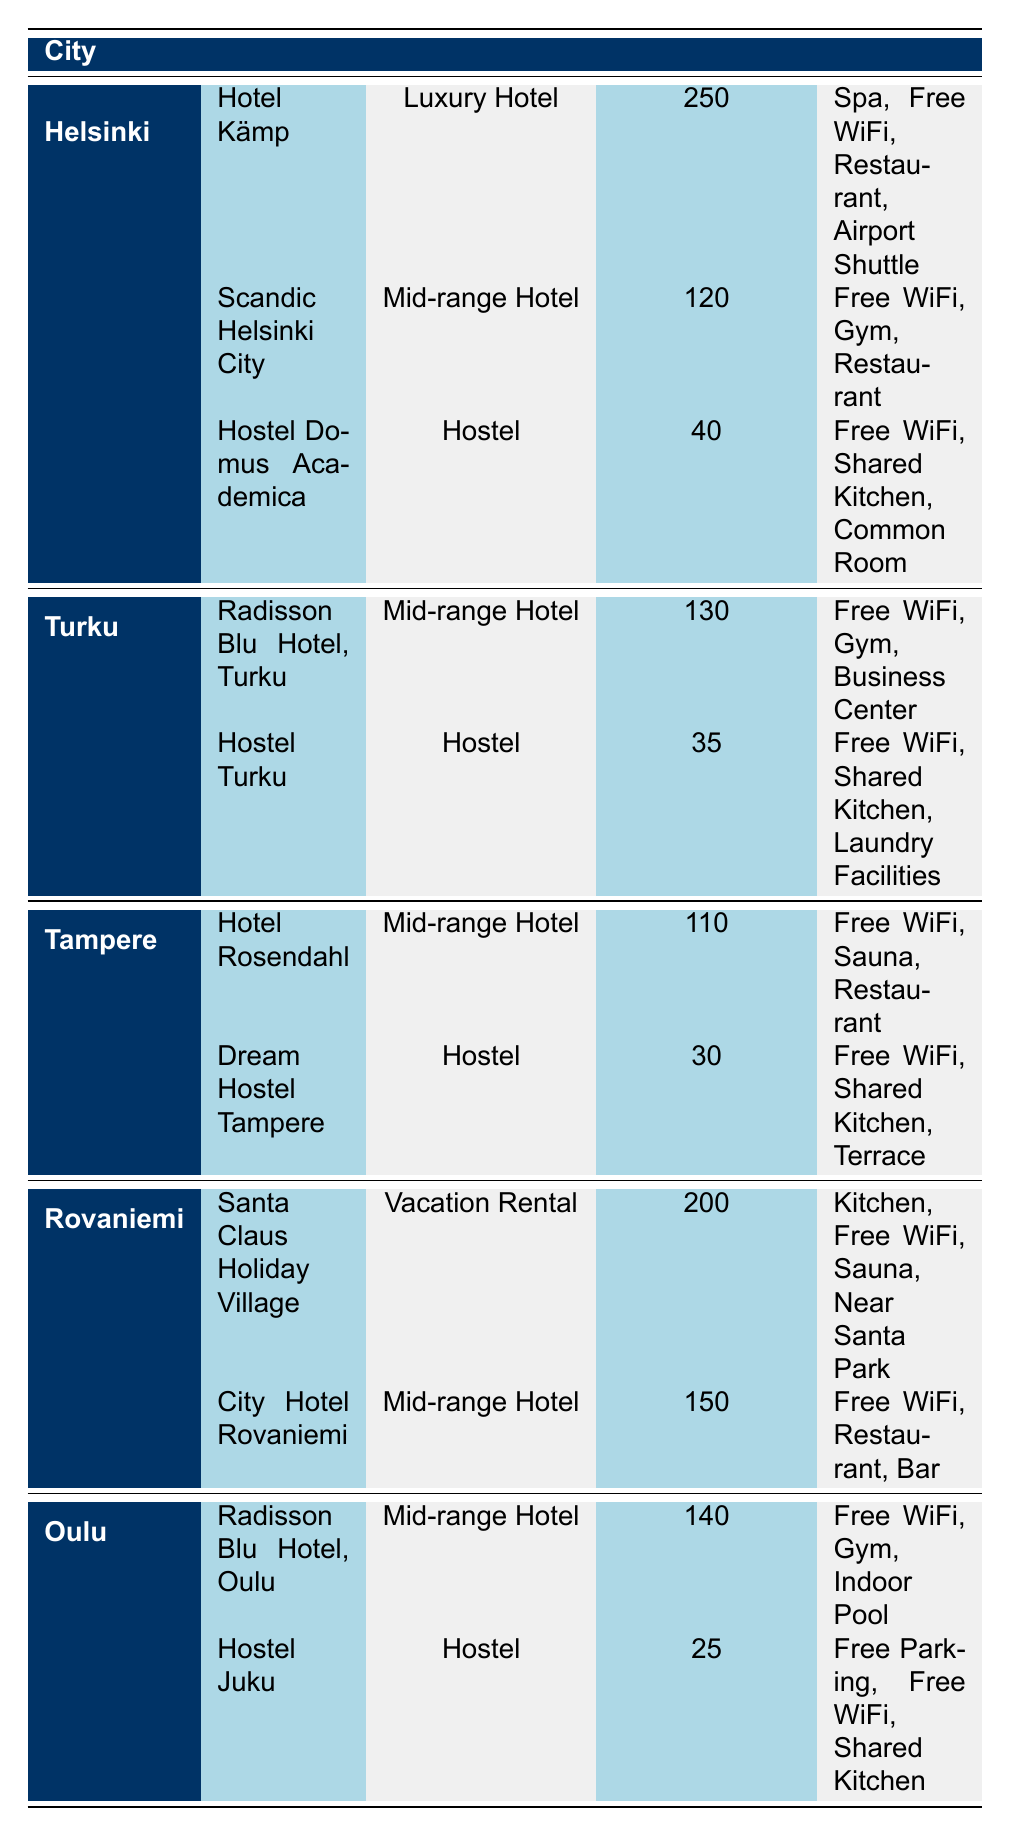What is the most expensive hotel in Helsinki? The table indicates that "Hotel Kämp" is the most expensive hotel in Helsinki, with a price of 250 euros per night.
Answer: Hotel Kämp How much does it cost to stay at the cheapest hostel in Oulu? The cheapest hostel in Oulu is "Hostel Juku", which costs 25 euros per night.
Answer: 25 euros Which city has the highest average hotel price? To find the highest average price, we need to calculate the average for each city. Helsinki has prices of 250, 120, and 40 (total: 410, average: 136.67). Turku has prices of 130 and 35 (total: 165, average: 82.5). Tampere has prices of 110 and 30 (total: 140, average: 70). Rovaniemi has prices of 200 and 150 (total: 350, average: 175). Oulu has prices of 140 and 25 (total: 165, average: 82.5). Therefore, Helsinki has the highest average hotel price of 136.67 euros.
Answer: Helsinki Is there a vacation rental option available in Rovaniemi? Yes, "Santa Claus Holiday Village" is listed as a vacation rental in Rovaniemi.
Answer: Yes What is the total price difference between the most expensive and the cheapest accommodation options listed? The most expensive accommodation option is "Hotel Kämp" at 250 euros, and the cheapest is "Hostel Juku" at 25 euros. The price difference is calculated as 250 - 25 = 225 euros.
Answer: 225 euros How many hotels in Turku provide a gym as an amenity? The table shows that "Radisson Blu Hotel, Turku" is the only hotel in Turku that offers a gym among its amenities.
Answer: 1 Which city has the lowest average accommodation price? The average prices calculated for each city are as follows: Helsinki: 136.67 euros, Turku: 82.5 euros, Tampere: 70 euros, Rovaniemi: 175 euros, and Oulu: 82.5 euros. Therefore, Tampere has the lowest average accommodation price at 70 euros.
Answer: Tampere Are all hostels listed in the table offering free WiFi? Yes, each hostel listed (Hostel Domus Academica, Hostel Turku, Dream Hostel Tampere, and Hostel Juku) provides free WiFi as one of their amenities.
Answer: Yes 